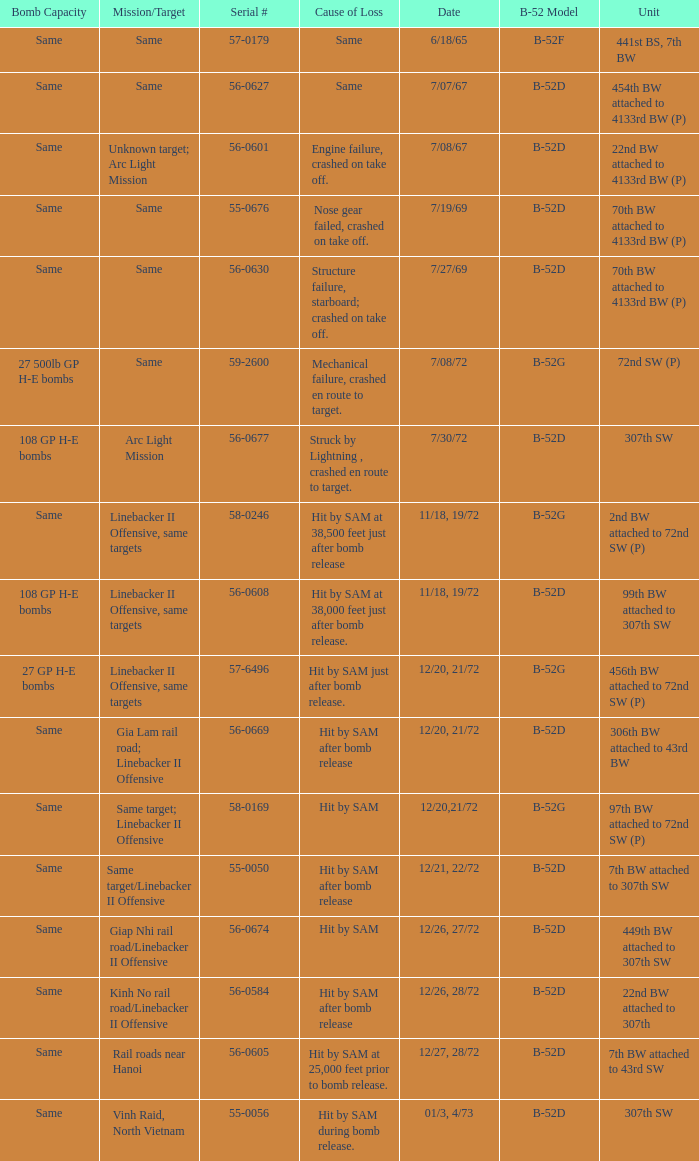When hit by sam at 38,500 feet just after bomb release was the cause of loss what is the mission/target? Linebacker II Offensive, same targets. 